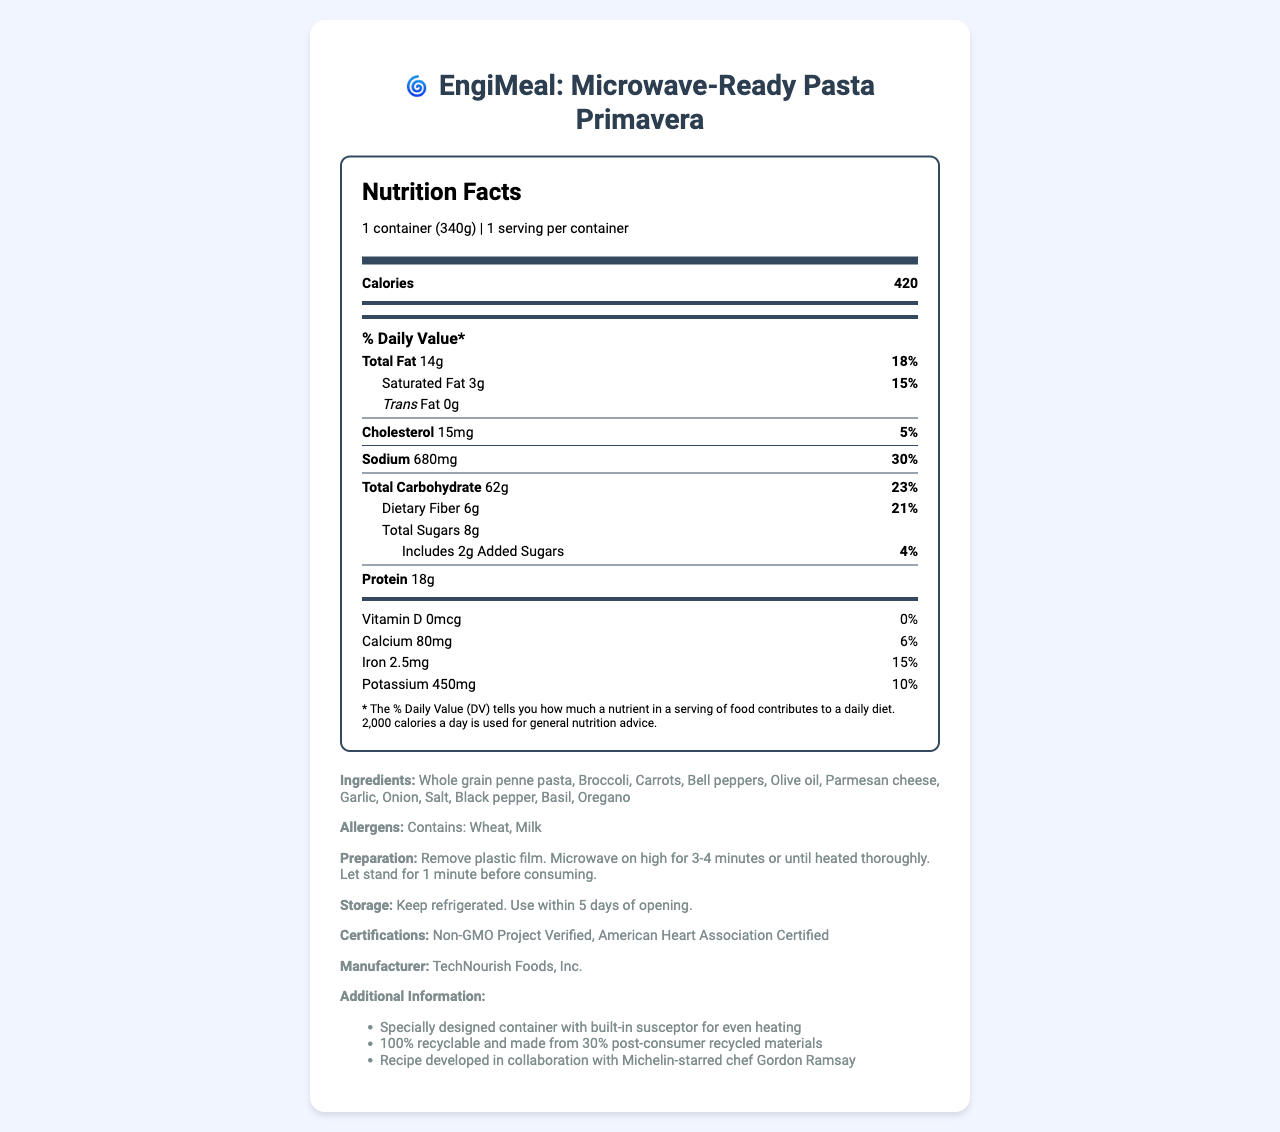what is the serving size of EngiMeal: Microwave-Ready Pasta Primavera? The serving size is explicitly listed in the document as "1 container (340g)".
Answer: 1 container (340g) how many calories are in one serving? The document states that there are 420 calories in one serving.
Answer: 420 which ingredient in EngiMeal contains allergens? The allergens section of the document specifies that the meal contains Wheat and Milk.
Answer: Wheat and Milk how much dietary fiber does the meal provide? The nutritional information section lists dietary fiber as 6 grams.
Answer: 6g who collaborated on the recipe development? The additional information section mentions that the recipe was developed in collaboration with Michelin-starred chef Gordon Ramsay.
Answer: Gordon Ramsay The total fat content is 14g. What percentage of the daily value does this represent? A. 10% B. 14% C. 18% D. 20% The document shows that the total fat content of 14 grams represents 18% of the daily value.
Answer: C what is the storage instruction for this product? The storage instructions are provided explicitly in the document.
Answer: Keep refrigerated. Use within 5 days of opening. which certification below does this product have? I. Non-GMO Project Verified II. Organic Certified III. Gluten Free The document lists two certifications: Non-GMO Project Verified and American Heart Association Certified. Organic Certified and Gluten-Free are not mentioned.
Answer: I how many grams of protein are in a serving? The nutritional label shows that one serving contains 18 grams of protein.
Answer: 18g is the packaging of the product eco-friendly? The additional information section mentions that the packaging is 100% recyclable and made from 30% post-consumer recycled materials.
Answer: Yes does this product contain any trans fat? The document states that the product contains 0 grams of trans fat.
Answer: No which cooking method is instructed for preparing the meal? The preparation instructions clearly state that you should microwave the meal on high for 3-4 minutes.
Answer: Microwave on high for 3-4 minutes summarize the main idea of this document. The document is an informational guide to the nutritional content, preparation methods, storage recommendations, and additional certifications for EngiMeal: Microwave-Ready Pasta Primavera, designed for busy professionals.
Answer: This document provides detailed nutrition facts about EngiMeal: Microwave-Ready Pasta Primavera, lists ingredients, allergens, storage and preparation instructions, and additional certifications and product features. what is the price of the EngiMeal: Microwave-Ready Pasta Primavera? The document does not contain any information about the price of the meal.
Answer: Cannot be determined 